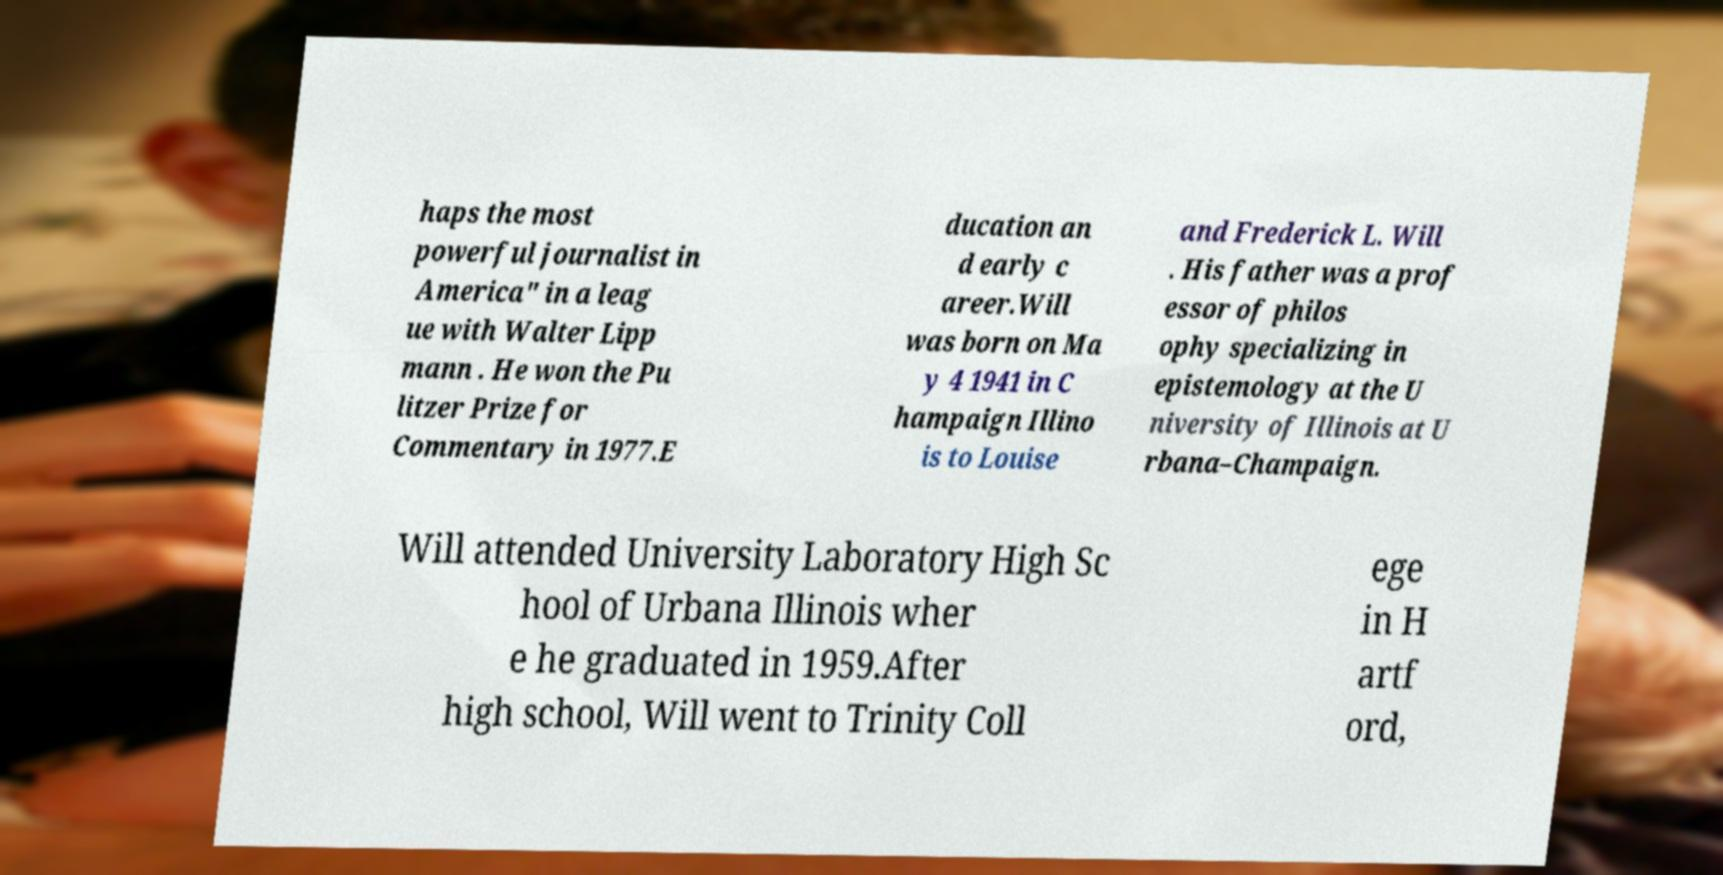Could you extract and type out the text from this image? haps the most powerful journalist in America" in a leag ue with Walter Lipp mann . He won the Pu litzer Prize for Commentary in 1977.E ducation an d early c areer.Will was born on Ma y 4 1941 in C hampaign Illino is to Louise and Frederick L. Will . His father was a prof essor of philos ophy specializing in epistemology at the U niversity of Illinois at U rbana–Champaign. Will attended University Laboratory High Sc hool of Urbana Illinois wher e he graduated in 1959.After high school, Will went to Trinity Coll ege in H artf ord, 